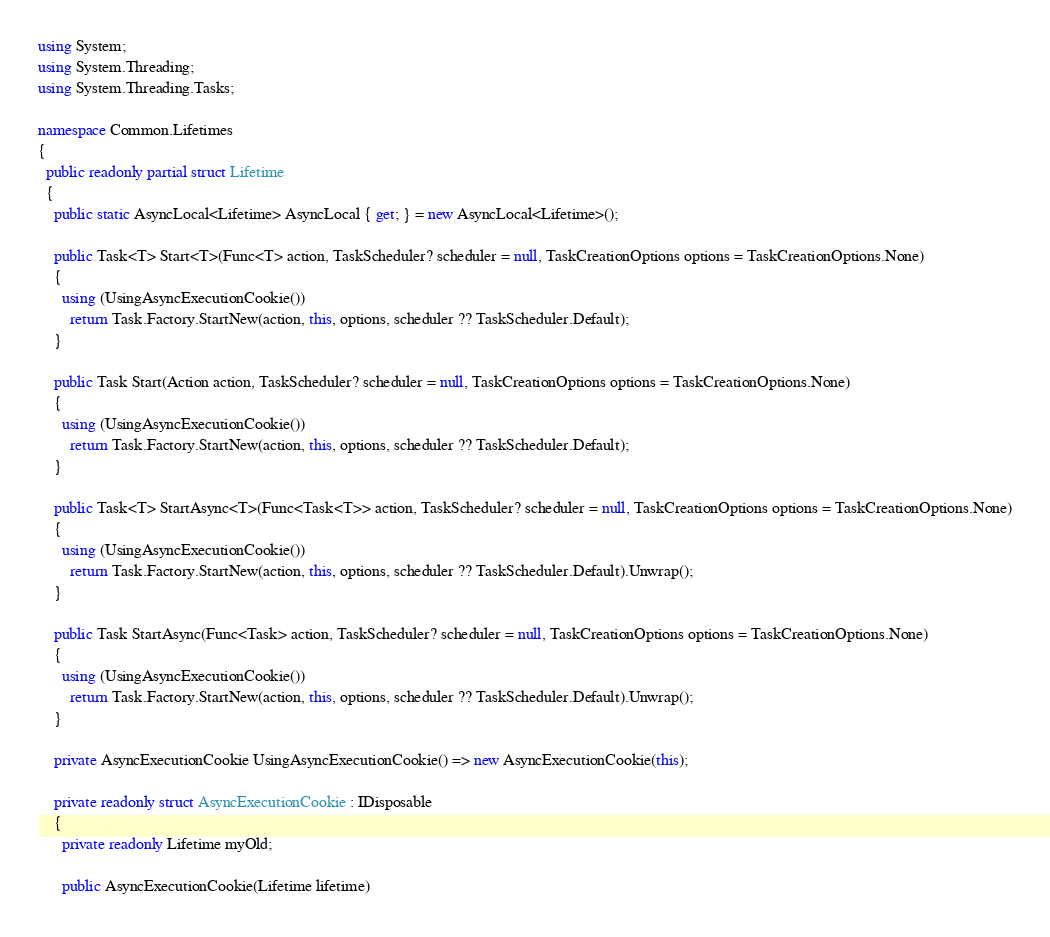Convert code to text. <code><loc_0><loc_0><loc_500><loc_500><_C#_>using System;
using System.Threading;
using System.Threading.Tasks;

namespace Common.Lifetimes
{
  public readonly partial struct Lifetime
  {
    public static AsyncLocal<Lifetime> AsyncLocal { get; } = new AsyncLocal<Lifetime>();

    public Task<T> Start<T>(Func<T> action, TaskScheduler? scheduler = null, TaskCreationOptions options = TaskCreationOptions.None)
    {
      using (UsingAsyncExecutionCookie())
        return Task.Factory.StartNew(action, this, options, scheduler ?? TaskScheduler.Default);
    }
    
    public Task Start(Action action, TaskScheduler? scheduler = null, TaskCreationOptions options = TaskCreationOptions.None)
    {
      using (UsingAsyncExecutionCookie())
        return Task.Factory.StartNew(action, this, options, scheduler ?? TaskScheduler.Default);
    }
    
    public Task<T> StartAsync<T>(Func<Task<T>> action, TaskScheduler? scheduler = null, TaskCreationOptions options = TaskCreationOptions.None)
    {
      using (UsingAsyncExecutionCookie())
        return Task.Factory.StartNew(action, this, options, scheduler ?? TaskScheduler.Default).Unwrap();
    }
    
    public Task StartAsync(Func<Task> action, TaskScheduler? scheduler = null, TaskCreationOptions options = TaskCreationOptions.None)
    {
      using (UsingAsyncExecutionCookie())
        return Task.Factory.StartNew(action, this, options, scheduler ?? TaskScheduler.Default).Unwrap();
    }
    
    private AsyncExecutionCookie UsingAsyncExecutionCookie() => new AsyncExecutionCookie(this);
    
    private readonly struct AsyncExecutionCookie : IDisposable
    {
      private readonly Lifetime myOld;

      public AsyncExecutionCookie(Lifetime lifetime)</code> 